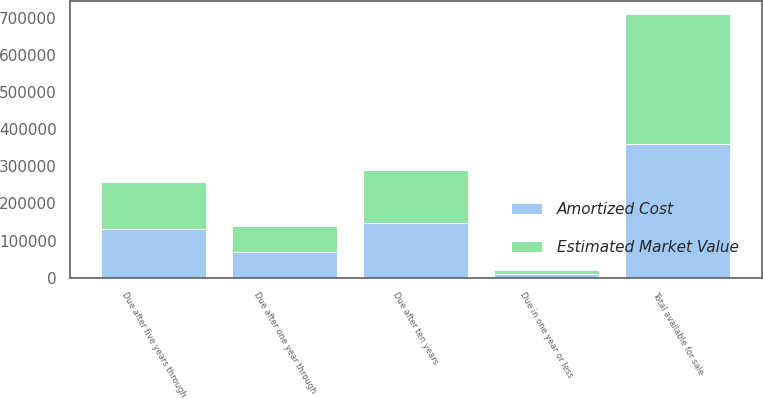<chart> <loc_0><loc_0><loc_500><loc_500><stacked_bar_chart><ecel><fcel>Due in one year or less<fcel>Due after one year through<fcel>Due after five years through<fcel>Due after ten years<fcel>Total available for sale<nl><fcel>Estimated Market Value<fcel>10417<fcel>68520<fcel>128353<fcel>142322<fcel>349612<nl><fcel>Amortized Cost<fcel>10991<fcel>70108<fcel>130446<fcel>147971<fcel>359516<nl></chart> 